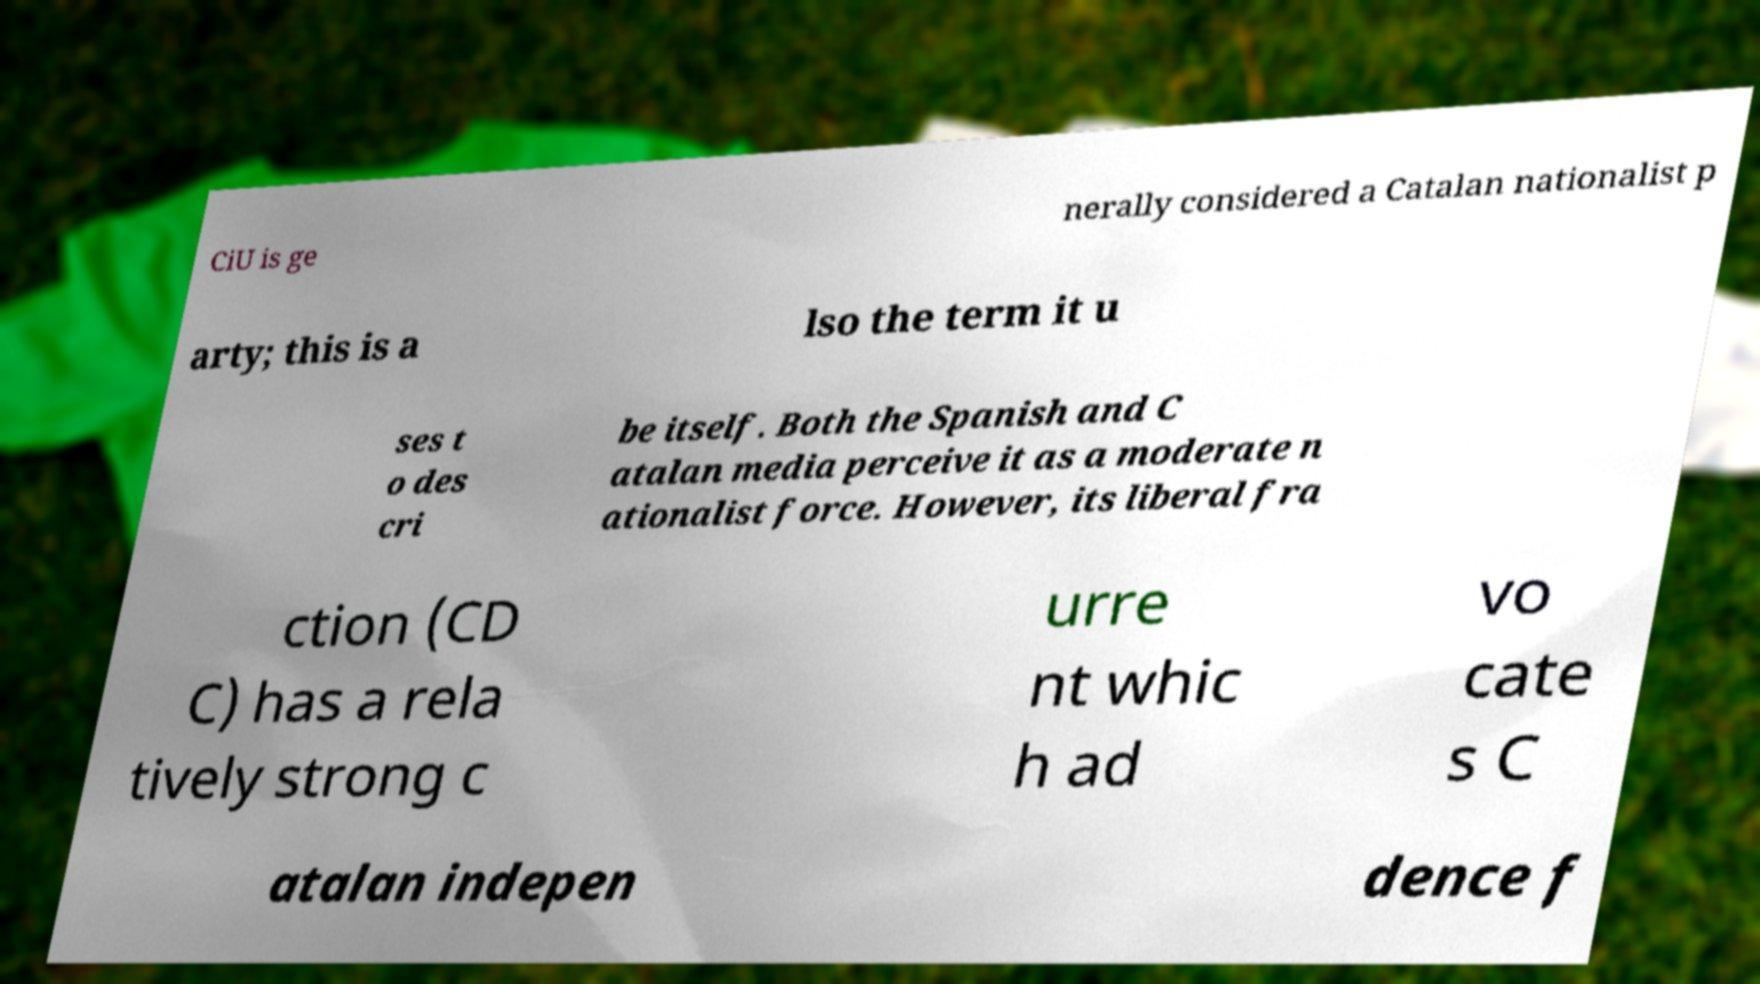Please read and relay the text visible in this image. What does it say? CiU is ge nerally considered a Catalan nationalist p arty; this is a lso the term it u ses t o des cri be itself. Both the Spanish and C atalan media perceive it as a moderate n ationalist force. However, its liberal fra ction (CD C) has a rela tively strong c urre nt whic h ad vo cate s C atalan indepen dence f 